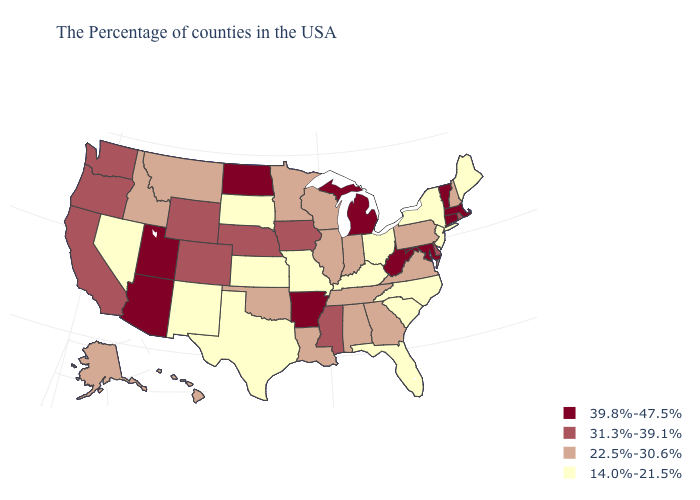Name the states that have a value in the range 14.0%-21.5%?
Be succinct. Maine, New York, New Jersey, North Carolina, South Carolina, Ohio, Florida, Kentucky, Missouri, Kansas, Texas, South Dakota, New Mexico, Nevada. How many symbols are there in the legend?
Give a very brief answer. 4. Does the map have missing data?
Concise answer only. No. Name the states that have a value in the range 22.5%-30.6%?
Answer briefly. New Hampshire, Pennsylvania, Virginia, Georgia, Indiana, Alabama, Tennessee, Wisconsin, Illinois, Louisiana, Minnesota, Oklahoma, Montana, Idaho, Alaska, Hawaii. Which states have the lowest value in the Northeast?
Be succinct. Maine, New York, New Jersey. Does the map have missing data?
Give a very brief answer. No. What is the highest value in the USA?
Give a very brief answer. 39.8%-47.5%. Among the states that border Utah , does Nevada have the lowest value?
Write a very short answer. Yes. Which states have the lowest value in the West?
Keep it brief. New Mexico, Nevada. Name the states that have a value in the range 31.3%-39.1%?
Quick response, please. Rhode Island, Delaware, Mississippi, Iowa, Nebraska, Wyoming, Colorado, California, Washington, Oregon. What is the value of Illinois?
Short answer required. 22.5%-30.6%. Among the states that border New York , which have the lowest value?
Concise answer only. New Jersey. Among the states that border Utah , does Nevada have the highest value?
Answer briefly. No. Among the states that border Rhode Island , which have the highest value?
Write a very short answer. Massachusetts, Connecticut. What is the value of Illinois?
Answer briefly. 22.5%-30.6%. 